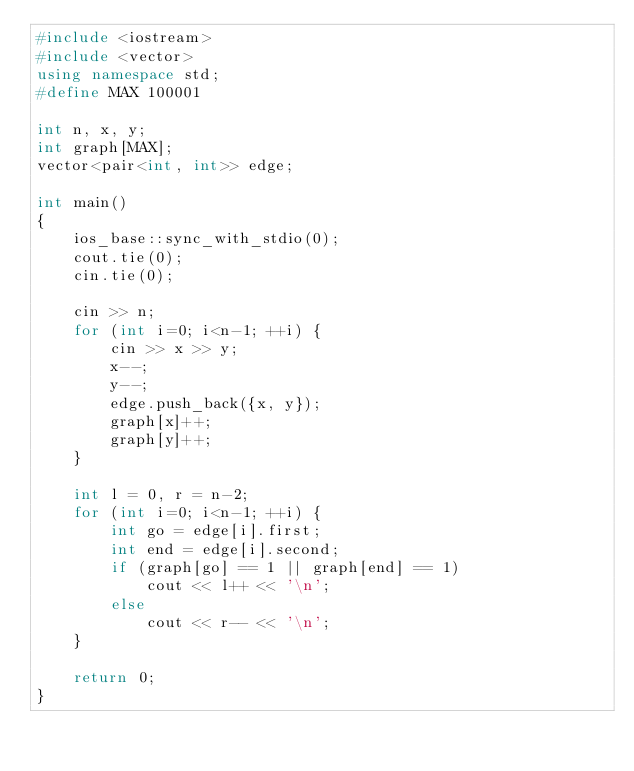<code> <loc_0><loc_0><loc_500><loc_500><_C++_>#include <iostream>
#include <vector>
using namespace std;
#define MAX 100001

int n, x, y;
int graph[MAX];
vector<pair<int, int>> edge;

int main()
{
	ios_base::sync_with_stdio(0);
	cout.tie(0);
	cin.tie(0);

	cin >> n;
	for (int i=0; i<n-1; ++i) {
		cin >> x >> y;
		x--;
		y--;
		edge.push_back({x, y});
		graph[x]++;
		graph[y]++;
	}

	int l = 0, r = n-2;
	for (int i=0; i<n-1; ++i) {
		int go = edge[i].first;
		int end = edge[i].second;
		if (graph[go] == 1 || graph[end] == 1)
			cout << l++ << '\n';
		else
			cout << r-- << '\n';
	}

	return 0;
}
</code> 